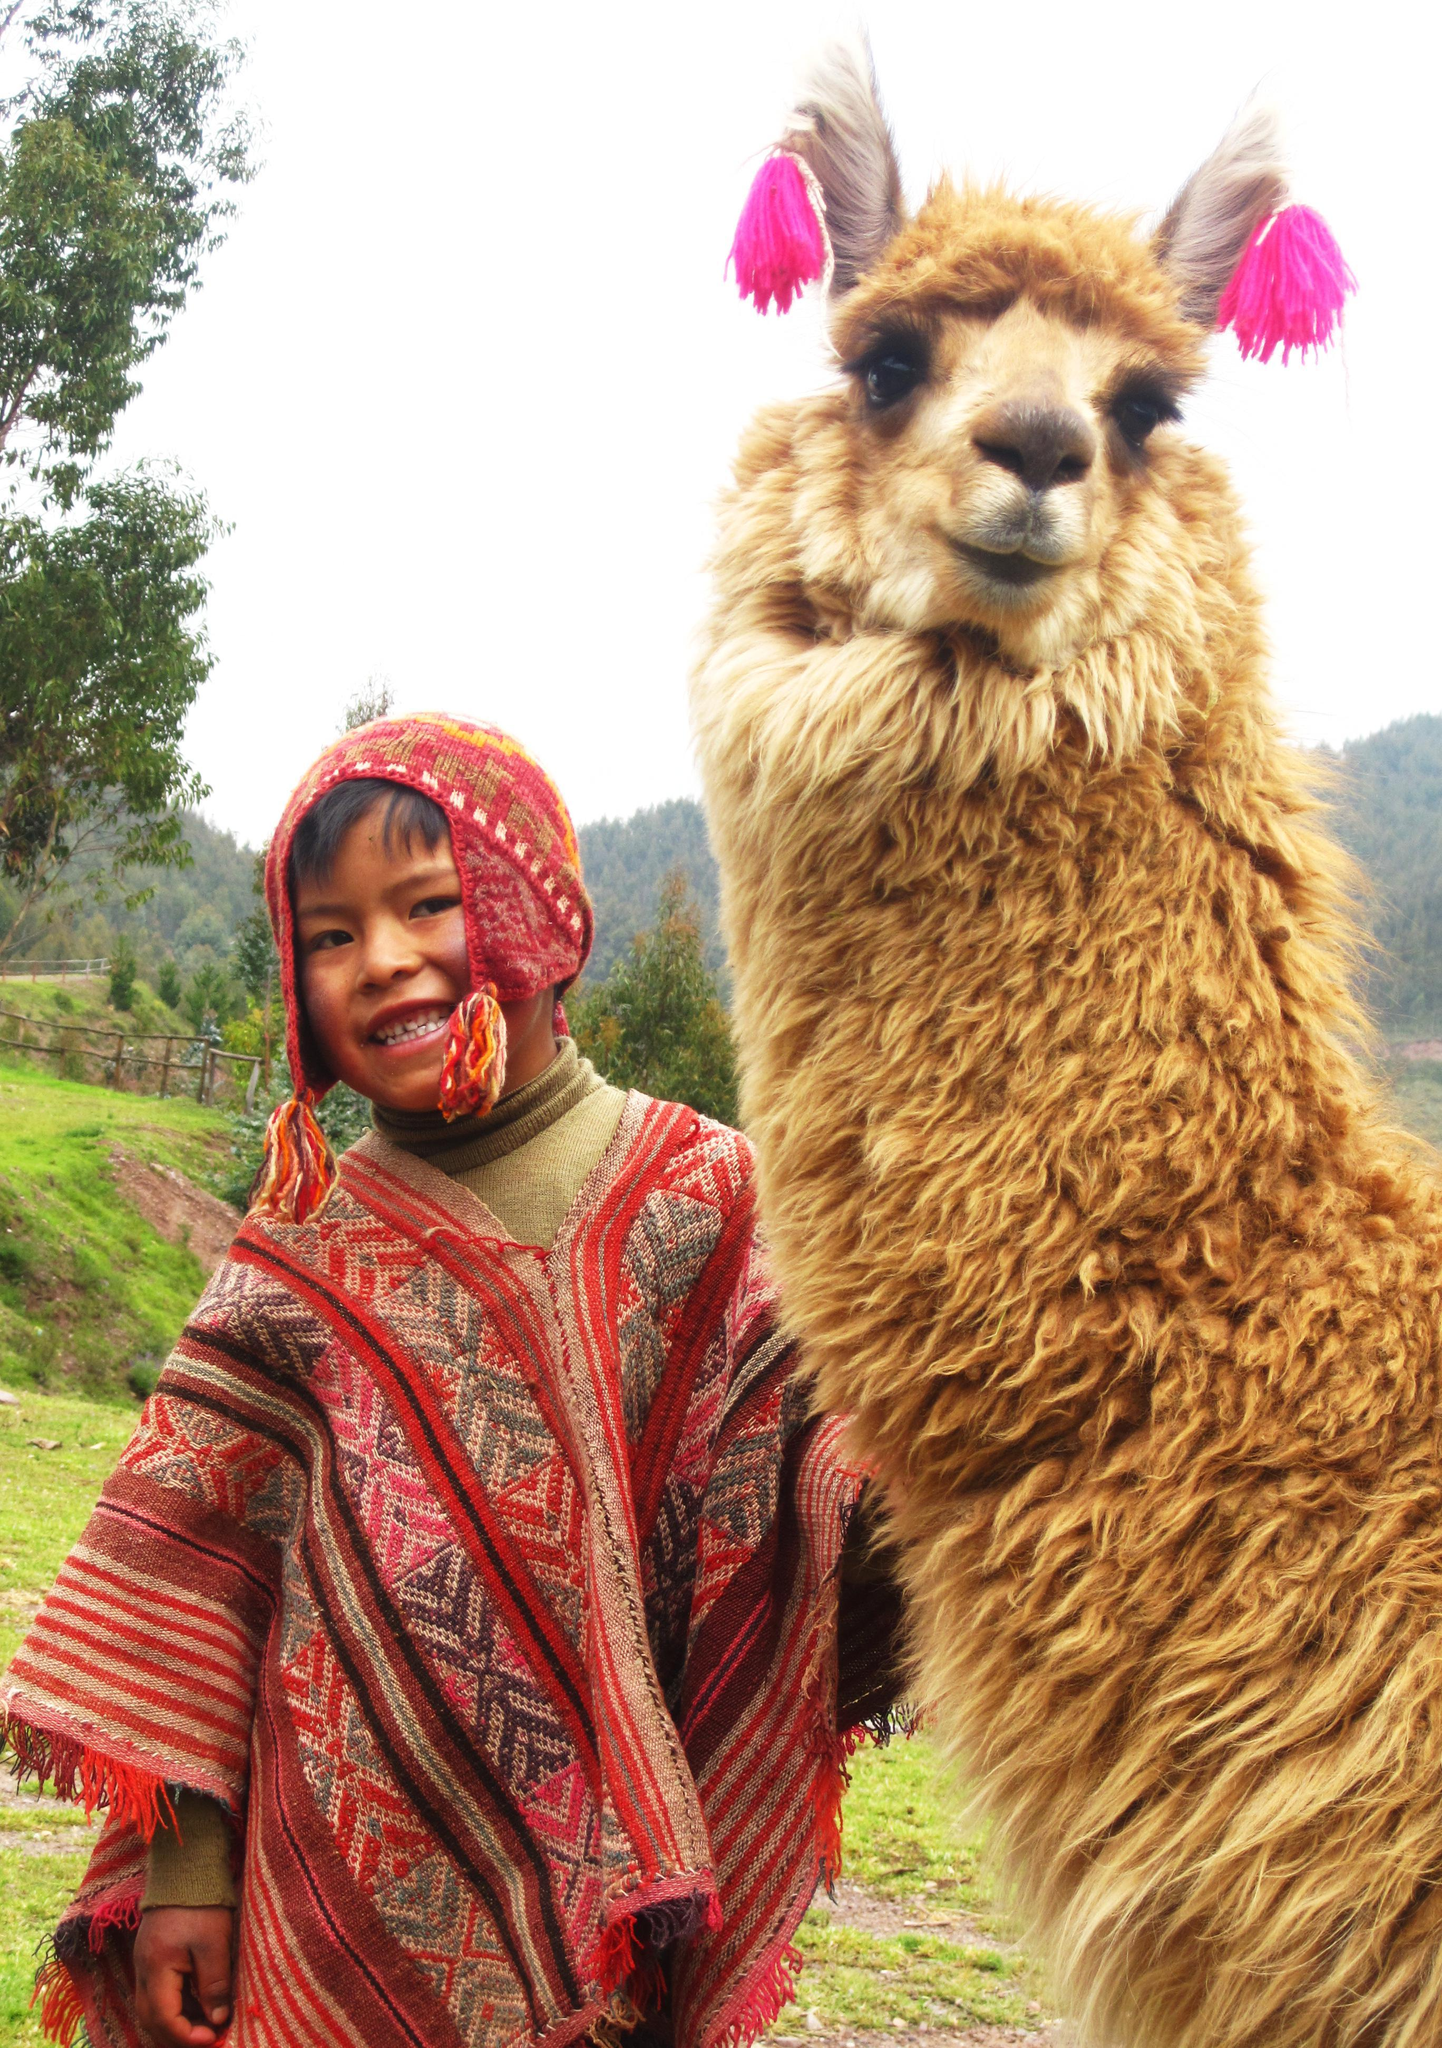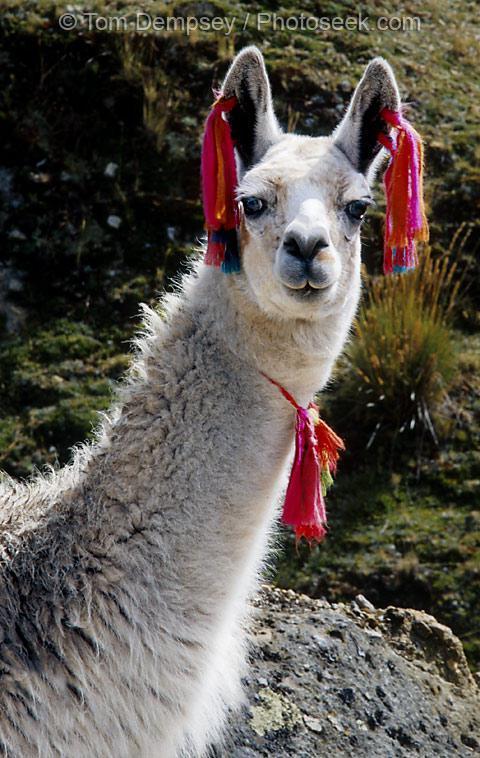The first image is the image on the left, the second image is the image on the right. Assess this claim about the two images: "In one image there is a person standing next to a llama and in the other image there is a llama decorated with yarn.". Correct or not? Answer yes or no. Yes. 